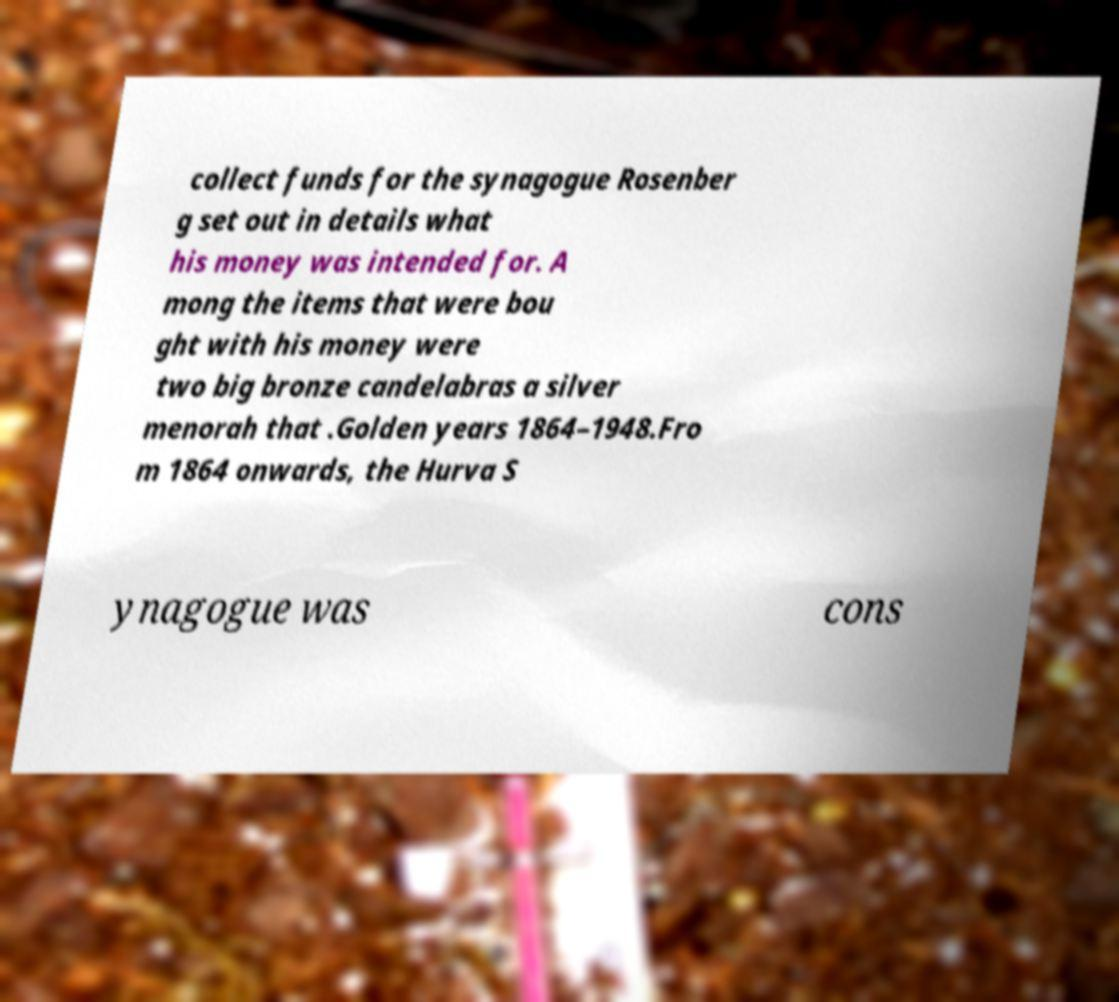Could you extract and type out the text from this image? collect funds for the synagogue Rosenber g set out in details what his money was intended for. A mong the items that were bou ght with his money were two big bronze candelabras a silver menorah that .Golden years 1864–1948.Fro m 1864 onwards, the Hurva S ynagogue was cons 